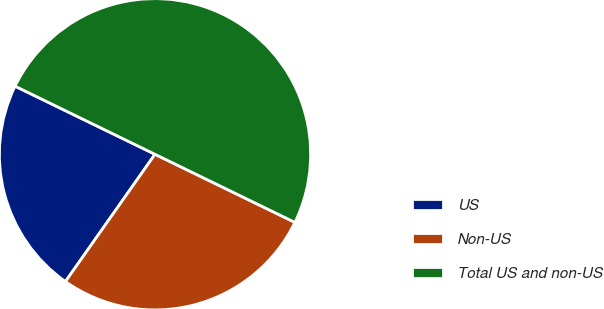<chart> <loc_0><loc_0><loc_500><loc_500><pie_chart><fcel>US<fcel>Non-US<fcel>Total US and non-US<nl><fcel>22.45%<fcel>27.55%<fcel>50.0%<nl></chart> 